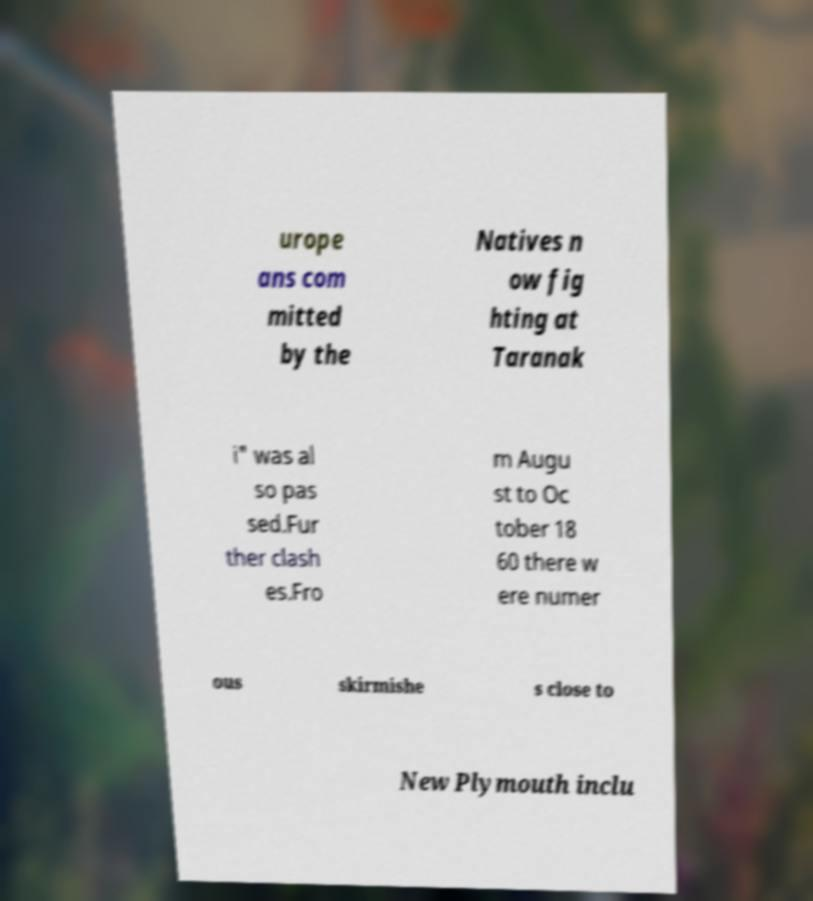For documentation purposes, I need the text within this image transcribed. Could you provide that? urope ans com mitted by the Natives n ow fig hting at Taranak i" was al so pas sed.Fur ther clash es.Fro m Augu st to Oc tober 18 60 there w ere numer ous skirmishe s close to New Plymouth inclu 